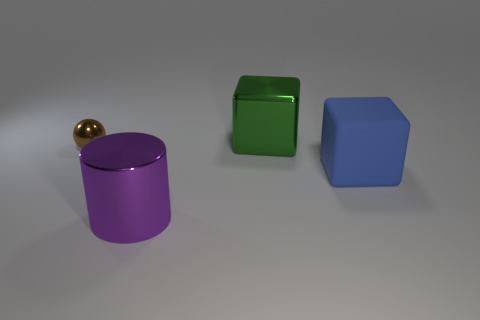Subtract all cylinders. How many objects are left? 3 Add 4 spheres. How many spheres exist? 5 Add 4 metallic spheres. How many objects exist? 8 Subtract 1 brown balls. How many objects are left? 3 Subtract 1 balls. How many balls are left? 0 Subtract all purple blocks. Subtract all gray spheres. How many blocks are left? 2 Subtract all red cubes. How many blue cylinders are left? 0 Subtract all cubes. Subtract all big purple objects. How many objects are left? 1 Add 1 big green blocks. How many big green blocks are left? 2 